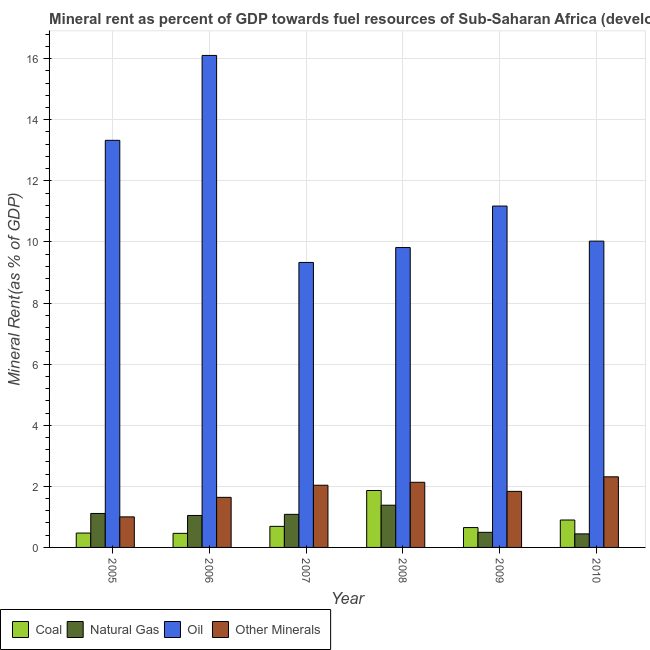How many different coloured bars are there?
Provide a succinct answer. 4. How many groups of bars are there?
Your response must be concise. 6. Are the number of bars per tick equal to the number of legend labels?
Make the answer very short. Yes. Are the number of bars on each tick of the X-axis equal?
Your response must be concise. Yes. What is the natural gas rent in 2006?
Provide a succinct answer. 1.05. Across all years, what is the maximum oil rent?
Ensure brevity in your answer.  16.1. Across all years, what is the minimum  rent of other minerals?
Provide a succinct answer. 1. In which year was the coal rent minimum?
Your answer should be very brief. 2006. What is the total oil rent in the graph?
Keep it short and to the point. 69.77. What is the difference between the natural gas rent in 2007 and that in 2010?
Your response must be concise. 0.64. What is the difference between the oil rent in 2008 and the natural gas rent in 2006?
Offer a terse response. -6.29. What is the average coal rent per year?
Ensure brevity in your answer.  0.84. In how many years, is the  rent of other minerals greater than 6.4 %?
Make the answer very short. 0. What is the ratio of the natural gas rent in 2005 to that in 2009?
Your answer should be compact. 2.25. Is the  rent of other minerals in 2005 less than that in 2006?
Provide a short and direct response. Yes. Is the difference between the coal rent in 2005 and 2007 greater than the difference between the oil rent in 2005 and 2007?
Give a very brief answer. No. What is the difference between the highest and the second highest coal rent?
Your response must be concise. 0.97. What is the difference between the highest and the lowest natural gas rent?
Make the answer very short. 0.94. Is the sum of the natural gas rent in 2006 and 2009 greater than the maximum oil rent across all years?
Offer a terse response. Yes. What does the 1st bar from the left in 2010 represents?
Offer a terse response. Coal. What does the 1st bar from the right in 2006 represents?
Make the answer very short. Other Minerals. Is it the case that in every year, the sum of the coal rent and natural gas rent is greater than the oil rent?
Make the answer very short. No. Are all the bars in the graph horizontal?
Give a very brief answer. No. How many years are there in the graph?
Your answer should be very brief. 6. What is the difference between two consecutive major ticks on the Y-axis?
Offer a very short reply. 2. Does the graph contain any zero values?
Provide a succinct answer. No. Does the graph contain grids?
Keep it short and to the point. Yes. How are the legend labels stacked?
Your answer should be compact. Horizontal. What is the title of the graph?
Offer a terse response. Mineral rent as percent of GDP towards fuel resources of Sub-Saharan Africa (developing only). Does "Other greenhouse gases" appear as one of the legend labels in the graph?
Give a very brief answer. No. What is the label or title of the X-axis?
Make the answer very short. Year. What is the label or title of the Y-axis?
Provide a short and direct response. Mineral Rent(as % of GDP). What is the Mineral Rent(as % of GDP) in Coal in 2005?
Your response must be concise. 0.47. What is the Mineral Rent(as % of GDP) in Natural Gas in 2005?
Your answer should be compact. 1.11. What is the Mineral Rent(as % of GDP) of Oil in 2005?
Provide a short and direct response. 13.33. What is the Mineral Rent(as % of GDP) in Other Minerals in 2005?
Your answer should be very brief. 1. What is the Mineral Rent(as % of GDP) of Coal in 2006?
Your response must be concise. 0.46. What is the Mineral Rent(as % of GDP) of Natural Gas in 2006?
Ensure brevity in your answer.  1.05. What is the Mineral Rent(as % of GDP) of Oil in 2006?
Your response must be concise. 16.1. What is the Mineral Rent(as % of GDP) of Other Minerals in 2006?
Make the answer very short. 1.64. What is the Mineral Rent(as % of GDP) of Coal in 2007?
Your response must be concise. 0.69. What is the Mineral Rent(as % of GDP) in Natural Gas in 2007?
Give a very brief answer. 1.08. What is the Mineral Rent(as % of GDP) of Oil in 2007?
Give a very brief answer. 9.33. What is the Mineral Rent(as % of GDP) in Other Minerals in 2007?
Provide a succinct answer. 2.04. What is the Mineral Rent(as % of GDP) in Coal in 2008?
Your answer should be compact. 1.86. What is the Mineral Rent(as % of GDP) in Natural Gas in 2008?
Ensure brevity in your answer.  1.38. What is the Mineral Rent(as % of GDP) in Oil in 2008?
Ensure brevity in your answer.  9.82. What is the Mineral Rent(as % of GDP) in Other Minerals in 2008?
Offer a very short reply. 2.13. What is the Mineral Rent(as % of GDP) of Coal in 2009?
Make the answer very short. 0.65. What is the Mineral Rent(as % of GDP) in Natural Gas in 2009?
Keep it short and to the point. 0.49. What is the Mineral Rent(as % of GDP) in Oil in 2009?
Give a very brief answer. 11.17. What is the Mineral Rent(as % of GDP) of Other Minerals in 2009?
Offer a terse response. 1.83. What is the Mineral Rent(as % of GDP) in Coal in 2010?
Provide a succinct answer. 0.9. What is the Mineral Rent(as % of GDP) in Natural Gas in 2010?
Your response must be concise. 0.44. What is the Mineral Rent(as % of GDP) of Oil in 2010?
Provide a succinct answer. 10.03. What is the Mineral Rent(as % of GDP) in Other Minerals in 2010?
Provide a succinct answer. 2.31. Across all years, what is the maximum Mineral Rent(as % of GDP) in Coal?
Offer a terse response. 1.86. Across all years, what is the maximum Mineral Rent(as % of GDP) in Natural Gas?
Your response must be concise. 1.38. Across all years, what is the maximum Mineral Rent(as % of GDP) in Oil?
Provide a succinct answer. 16.1. Across all years, what is the maximum Mineral Rent(as % of GDP) of Other Minerals?
Offer a very short reply. 2.31. Across all years, what is the minimum Mineral Rent(as % of GDP) of Coal?
Provide a short and direct response. 0.46. Across all years, what is the minimum Mineral Rent(as % of GDP) of Natural Gas?
Offer a terse response. 0.44. Across all years, what is the minimum Mineral Rent(as % of GDP) of Oil?
Give a very brief answer. 9.33. Across all years, what is the minimum Mineral Rent(as % of GDP) of Other Minerals?
Offer a very short reply. 1. What is the total Mineral Rent(as % of GDP) in Coal in the graph?
Your response must be concise. 5.03. What is the total Mineral Rent(as % of GDP) in Natural Gas in the graph?
Your response must be concise. 5.56. What is the total Mineral Rent(as % of GDP) of Oil in the graph?
Give a very brief answer. 69.77. What is the total Mineral Rent(as % of GDP) in Other Minerals in the graph?
Ensure brevity in your answer.  10.95. What is the difference between the Mineral Rent(as % of GDP) of Coal in 2005 and that in 2006?
Provide a succinct answer. 0.01. What is the difference between the Mineral Rent(as % of GDP) in Natural Gas in 2005 and that in 2006?
Your answer should be compact. 0.07. What is the difference between the Mineral Rent(as % of GDP) in Oil in 2005 and that in 2006?
Your answer should be very brief. -2.78. What is the difference between the Mineral Rent(as % of GDP) of Other Minerals in 2005 and that in 2006?
Make the answer very short. -0.64. What is the difference between the Mineral Rent(as % of GDP) in Coal in 2005 and that in 2007?
Provide a succinct answer. -0.22. What is the difference between the Mineral Rent(as % of GDP) in Natural Gas in 2005 and that in 2007?
Make the answer very short. 0.03. What is the difference between the Mineral Rent(as % of GDP) of Oil in 2005 and that in 2007?
Offer a terse response. 4. What is the difference between the Mineral Rent(as % of GDP) in Other Minerals in 2005 and that in 2007?
Offer a very short reply. -1.04. What is the difference between the Mineral Rent(as % of GDP) in Coal in 2005 and that in 2008?
Your response must be concise. -1.39. What is the difference between the Mineral Rent(as % of GDP) in Natural Gas in 2005 and that in 2008?
Ensure brevity in your answer.  -0.27. What is the difference between the Mineral Rent(as % of GDP) of Oil in 2005 and that in 2008?
Give a very brief answer. 3.51. What is the difference between the Mineral Rent(as % of GDP) in Other Minerals in 2005 and that in 2008?
Provide a succinct answer. -1.13. What is the difference between the Mineral Rent(as % of GDP) of Coal in 2005 and that in 2009?
Keep it short and to the point. -0.18. What is the difference between the Mineral Rent(as % of GDP) of Natural Gas in 2005 and that in 2009?
Provide a succinct answer. 0.62. What is the difference between the Mineral Rent(as % of GDP) of Oil in 2005 and that in 2009?
Keep it short and to the point. 2.15. What is the difference between the Mineral Rent(as % of GDP) in Other Minerals in 2005 and that in 2009?
Provide a short and direct response. -0.83. What is the difference between the Mineral Rent(as % of GDP) in Coal in 2005 and that in 2010?
Offer a very short reply. -0.43. What is the difference between the Mineral Rent(as % of GDP) in Natural Gas in 2005 and that in 2010?
Provide a succinct answer. 0.67. What is the difference between the Mineral Rent(as % of GDP) of Oil in 2005 and that in 2010?
Provide a short and direct response. 3.3. What is the difference between the Mineral Rent(as % of GDP) in Other Minerals in 2005 and that in 2010?
Offer a terse response. -1.31. What is the difference between the Mineral Rent(as % of GDP) in Coal in 2006 and that in 2007?
Your answer should be compact. -0.23. What is the difference between the Mineral Rent(as % of GDP) in Natural Gas in 2006 and that in 2007?
Provide a succinct answer. -0.04. What is the difference between the Mineral Rent(as % of GDP) in Oil in 2006 and that in 2007?
Your response must be concise. 6.78. What is the difference between the Mineral Rent(as % of GDP) in Other Minerals in 2006 and that in 2007?
Your answer should be compact. -0.4. What is the difference between the Mineral Rent(as % of GDP) in Coal in 2006 and that in 2008?
Provide a short and direct response. -1.4. What is the difference between the Mineral Rent(as % of GDP) of Natural Gas in 2006 and that in 2008?
Ensure brevity in your answer.  -0.34. What is the difference between the Mineral Rent(as % of GDP) of Oil in 2006 and that in 2008?
Your answer should be very brief. 6.29. What is the difference between the Mineral Rent(as % of GDP) in Other Minerals in 2006 and that in 2008?
Offer a terse response. -0.49. What is the difference between the Mineral Rent(as % of GDP) of Coal in 2006 and that in 2009?
Your answer should be very brief. -0.19. What is the difference between the Mineral Rent(as % of GDP) in Natural Gas in 2006 and that in 2009?
Ensure brevity in your answer.  0.55. What is the difference between the Mineral Rent(as % of GDP) of Oil in 2006 and that in 2009?
Your answer should be compact. 4.93. What is the difference between the Mineral Rent(as % of GDP) of Other Minerals in 2006 and that in 2009?
Provide a short and direct response. -0.19. What is the difference between the Mineral Rent(as % of GDP) of Coal in 2006 and that in 2010?
Make the answer very short. -0.44. What is the difference between the Mineral Rent(as % of GDP) in Natural Gas in 2006 and that in 2010?
Keep it short and to the point. 0.6. What is the difference between the Mineral Rent(as % of GDP) in Oil in 2006 and that in 2010?
Keep it short and to the point. 6.08. What is the difference between the Mineral Rent(as % of GDP) of Other Minerals in 2006 and that in 2010?
Ensure brevity in your answer.  -0.67. What is the difference between the Mineral Rent(as % of GDP) in Coal in 2007 and that in 2008?
Your answer should be compact. -1.17. What is the difference between the Mineral Rent(as % of GDP) in Natural Gas in 2007 and that in 2008?
Offer a terse response. -0.3. What is the difference between the Mineral Rent(as % of GDP) of Oil in 2007 and that in 2008?
Provide a succinct answer. -0.49. What is the difference between the Mineral Rent(as % of GDP) in Other Minerals in 2007 and that in 2008?
Provide a short and direct response. -0.1. What is the difference between the Mineral Rent(as % of GDP) of Coal in 2007 and that in 2009?
Provide a short and direct response. 0.04. What is the difference between the Mineral Rent(as % of GDP) of Natural Gas in 2007 and that in 2009?
Keep it short and to the point. 0.59. What is the difference between the Mineral Rent(as % of GDP) in Oil in 2007 and that in 2009?
Offer a terse response. -1.85. What is the difference between the Mineral Rent(as % of GDP) in Other Minerals in 2007 and that in 2009?
Give a very brief answer. 0.2. What is the difference between the Mineral Rent(as % of GDP) in Coal in 2007 and that in 2010?
Give a very brief answer. -0.21. What is the difference between the Mineral Rent(as % of GDP) in Natural Gas in 2007 and that in 2010?
Keep it short and to the point. 0.64. What is the difference between the Mineral Rent(as % of GDP) of Oil in 2007 and that in 2010?
Your response must be concise. -0.7. What is the difference between the Mineral Rent(as % of GDP) of Other Minerals in 2007 and that in 2010?
Your response must be concise. -0.28. What is the difference between the Mineral Rent(as % of GDP) of Coal in 2008 and that in 2009?
Make the answer very short. 1.21. What is the difference between the Mineral Rent(as % of GDP) in Natural Gas in 2008 and that in 2009?
Keep it short and to the point. 0.89. What is the difference between the Mineral Rent(as % of GDP) in Oil in 2008 and that in 2009?
Your answer should be compact. -1.36. What is the difference between the Mineral Rent(as % of GDP) of Other Minerals in 2008 and that in 2009?
Offer a very short reply. 0.3. What is the difference between the Mineral Rent(as % of GDP) in Coal in 2008 and that in 2010?
Make the answer very short. 0.97. What is the difference between the Mineral Rent(as % of GDP) of Natural Gas in 2008 and that in 2010?
Your answer should be compact. 0.94. What is the difference between the Mineral Rent(as % of GDP) of Oil in 2008 and that in 2010?
Ensure brevity in your answer.  -0.21. What is the difference between the Mineral Rent(as % of GDP) of Other Minerals in 2008 and that in 2010?
Provide a succinct answer. -0.18. What is the difference between the Mineral Rent(as % of GDP) of Coal in 2009 and that in 2010?
Your answer should be very brief. -0.25. What is the difference between the Mineral Rent(as % of GDP) of Natural Gas in 2009 and that in 2010?
Keep it short and to the point. 0.05. What is the difference between the Mineral Rent(as % of GDP) in Oil in 2009 and that in 2010?
Offer a very short reply. 1.15. What is the difference between the Mineral Rent(as % of GDP) of Other Minerals in 2009 and that in 2010?
Keep it short and to the point. -0.48. What is the difference between the Mineral Rent(as % of GDP) in Coal in 2005 and the Mineral Rent(as % of GDP) in Natural Gas in 2006?
Offer a very short reply. -0.58. What is the difference between the Mineral Rent(as % of GDP) in Coal in 2005 and the Mineral Rent(as % of GDP) in Oil in 2006?
Keep it short and to the point. -15.63. What is the difference between the Mineral Rent(as % of GDP) in Coal in 2005 and the Mineral Rent(as % of GDP) in Other Minerals in 2006?
Offer a very short reply. -1.17. What is the difference between the Mineral Rent(as % of GDP) in Natural Gas in 2005 and the Mineral Rent(as % of GDP) in Oil in 2006?
Make the answer very short. -14.99. What is the difference between the Mineral Rent(as % of GDP) of Natural Gas in 2005 and the Mineral Rent(as % of GDP) of Other Minerals in 2006?
Your response must be concise. -0.53. What is the difference between the Mineral Rent(as % of GDP) of Oil in 2005 and the Mineral Rent(as % of GDP) of Other Minerals in 2006?
Offer a very short reply. 11.69. What is the difference between the Mineral Rent(as % of GDP) in Coal in 2005 and the Mineral Rent(as % of GDP) in Natural Gas in 2007?
Offer a terse response. -0.61. What is the difference between the Mineral Rent(as % of GDP) in Coal in 2005 and the Mineral Rent(as % of GDP) in Oil in 2007?
Keep it short and to the point. -8.86. What is the difference between the Mineral Rent(as % of GDP) in Coal in 2005 and the Mineral Rent(as % of GDP) in Other Minerals in 2007?
Offer a very short reply. -1.57. What is the difference between the Mineral Rent(as % of GDP) in Natural Gas in 2005 and the Mineral Rent(as % of GDP) in Oil in 2007?
Keep it short and to the point. -8.22. What is the difference between the Mineral Rent(as % of GDP) in Natural Gas in 2005 and the Mineral Rent(as % of GDP) in Other Minerals in 2007?
Ensure brevity in your answer.  -0.92. What is the difference between the Mineral Rent(as % of GDP) of Oil in 2005 and the Mineral Rent(as % of GDP) of Other Minerals in 2007?
Ensure brevity in your answer.  11.29. What is the difference between the Mineral Rent(as % of GDP) in Coal in 2005 and the Mineral Rent(as % of GDP) in Natural Gas in 2008?
Your response must be concise. -0.91. What is the difference between the Mineral Rent(as % of GDP) in Coal in 2005 and the Mineral Rent(as % of GDP) in Oil in 2008?
Give a very brief answer. -9.35. What is the difference between the Mineral Rent(as % of GDP) in Coal in 2005 and the Mineral Rent(as % of GDP) in Other Minerals in 2008?
Make the answer very short. -1.66. What is the difference between the Mineral Rent(as % of GDP) in Natural Gas in 2005 and the Mineral Rent(as % of GDP) in Oil in 2008?
Your answer should be compact. -8.7. What is the difference between the Mineral Rent(as % of GDP) in Natural Gas in 2005 and the Mineral Rent(as % of GDP) in Other Minerals in 2008?
Keep it short and to the point. -1.02. What is the difference between the Mineral Rent(as % of GDP) in Oil in 2005 and the Mineral Rent(as % of GDP) in Other Minerals in 2008?
Your response must be concise. 11.19. What is the difference between the Mineral Rent(as % of GDP) of Coal in 2005 and the Mineral Rent(as % of GDP) of Natural Gas in 2009?
Offer a terse response. -0.02. What is the difference between the Mineral Rent(as % of GDP) of Coal in 2005 and the Mineral Rent(as % of GDP) of Oil in 2009?
Provide a short and direct response. -10.7. What is the difference between the Mineral Rent(as % of GDP) in Coal in 2005 and the Mineral Rent(as % of GDP) in Other Minerals in 2009?
Your answer should be compact. -1.36. What is the difference between the Mineral Rent(as % of GDP) in Natural Gas in 2005 and the Mineral Rent(as % of GDP) in Oil in 2009?
Offer a very short reply. -10.06. What is the difference between the Mineral Rent(as % of GDP) in Natural Gas in 2005 and the Mineral Rent(as % of GDP) in Other Minerals in 2009?
Your answer should be very brief. -0.72. What is the difference between the Mineral Rent(as % of GDP) of Oil in 2005 and the Mineral Rent(as % of GDP) of Other Minerals in 2009?
Offer a terse response. 11.49. What is the difference between the Mineral Rent(as % of GDP) of Coal in 2005 and the Mineral Rent(as % of GDP) of Natural Gas in 2010?
Keep it short and to the point. 0.03. What is the difference between the Mineral Rent(as % of GDP) in Coal in 2005 and the Mineral Rent(as % of GDP) in Oil in 2010?
Ensure brevity in your answer.  -9.56. What is the difference between the Mineral Rent(as % of GDP) of Coal in 2005 and the Mineral Rent(as % of GDP) of Other Minerals in 2010?
Ensure brevity in your answer.  -1.84. What is the difference between the Mineral Rent(as % of GDP) of Natural Gas in 2005 and the Mineral Rent(as % of GDP) of Oil in 2010?
Your answer should be very brief. -8.91. What is the difference between the Mineral Rent(as % of GDP) of Natural Gas in 2005 and the Mineral Rent(as % of GDP) of Other Minerals in 2010?
Give a very brief answer. -1.2. What is the difference between the Mineral Rent(as % of GDP) of Oil in 2005 and the Mineral Rent(as % of GDP) of Other Minerals in 2010?
Ensure brevity in your answer.  11.01. What is the difference between the Mineral Rent(as % of GDP) in Coal in 2006 and the Mineral Rent(as % of GDP) in Natural Gas in 2007?
Provide a short and direct response. -0.62. What is the difference between the Mineral Rent(as % of GDP) of Coal in 2006 and the Mineral Rent(as % of GDP) of Oil in 2007?
Keep it short and to the point. -8.87. What is the difference between the Mineral Rent(as % of GDP) of Coal in 2006 and the Mineral Rent(as % of GDP) of Other Minerals in 2007?
Give a very brief answer. -1.57. What is the difference between the Mineral Rent(as % of GDP) in Natural Gas in 2006 and the Mineral Rent(as % of GDP) in Oil in 2007?
Your answer should be very brief. -8.28. What is the difference between the Mineral Rent(as % of GDP) of Natural Gas in 2006 and the Mineral Rent(as % of GDP) of Other Minerals in 2007?
Your answer should be very brief. -0.99. What is the difference between the Mineral Rent(as % of GDP) in Oil in 2006 and the Mineral Rent(as % of GDP) in Other Minerals in 2007?
Your response must be concise. 14.07. What is the difference between the Mineral Rent(as % of GDP) in Coal in 2006 and the Mineral Rent(as % of GDP) in Natural Gas in 2008?
Make the answer very short. -0.92. What is the difference between the Mineral Rent(as % of GDP) in Coal in 2006 and the Mineral Rent(as % of GDP) in Oil in 2008?
Provide a succinct answer. -9.35. What is the difference between the Mineral Rent(as % of GDP) of Coal in 2006 and the Mineral Rent(as % of GDP) of Other Minerals in 2008?
Give a very brief answer. -1.67. What is the difference between the Mineral Rent(as % of GDP) of Natural Gas in 2006 and the Mineral Rent(as % of GDP) of Oil in 2008?
Your response must be concise. -8.77. What is the difference between the Mineral Rent(as % of GDP) in Natural Gas in 2006 and the Mineral Rent(as % of GDP) in Other Minerals in 2008?
Offer a terse response. -1.09. What is the difference between the Mineral Rent(as % of GDP) in Oil in 2006 and the Mineral Rent(as % of GDP) in Other Minerals in 2008?
Your response must be concise. 13.97. What is the difference between the Mineral Rent(as % of GDP) in Coal in 2006 and the Mineral Rent(as % of GDP) in Natural Gas in 2009?
Provide a succinct answer. -0.03. What is the difference between the Mineral Rent(as % of GDP) of Coal in 2006 and the Mineral Rent(as % of GDP) of Oil in 2009?
Your answer should be very brief. -10.71. What is the difference between the Mineral Rent(as % of GDP) of Coal in 2006 and the Mineral Rent(as % of GDP) of Other Minerals in 2009?
Provide a short and direct response. -1.37. What is the difference between the Mineral Rent(as % of GDP) in Natural Gas in 2006 and the Mineral Rent(as % of GDP) in Oil in 2009?
Make the answer very short. -10.13. What is the difference between the Mineral Rent(as % of GDP) in Natural Gas in 2006 and the Mineral Rent(as % of GDP) in Other Minerals in 2009?
Your answer should be compact. -0.79. What is the difference between the Mineral Rent(as % of GDP) in Oil in 2006 and the Mineral Rent(as % of GDP) in Other Minerals in 2009?
Your answer should be compact. 14.27. What is the difference between the Mineral Rent(as % of GDP) of Coal in 2006 and the Mineral Rent(as % of GDP) of Natural Gas in 2010?
Give a very brief answer. 0.02. What is the difference between the Mineral Rent(as % of GDP) of Coal in 2006 and the Mineral Rent(as % of GDP) of Oil in 2010?
Your answer should be very brief. -9.57. What is the difference between the Mineral Rent(as % of GDP) of Coal in 2006 and the Mineral Rent(as % of GDP) of Other Minerals in 2010?
Provide a short and direct response. -1.85. What is the difference between the Mineral Rent(as % of GDP) of Natural Gas in 2006 and the Mineral Rent(as % of GDP) of Oil in 2010?
Your answer should be compact. -8.98. What is the difference between the Mineral Rent(as % of GDP) of Natural Gas in 2006 and the Mineral Rent(as % of GDP) of Other Minerals in 2010?
Provide a short and direct response. -1.26. What is the difference between the Mineral Rent(as % of GDP) of Oil in 2006 and the Mineral Rent(as % of GDP) of Other Minerals in 2010?
Offer a terse response. 13.79. What is the difference between the Mineral Rent(as % of GDP) of Coal in 2007 and the Mineral Rent(as % of GDP) of Natural Gas in 2008?
Your answer should be compact. -0.69. What is the difference between the Mineral Rent(as % of GDP) in Coal in 2007 and the Mineral Rent(as % of GDP) in Oil in 2008?
Provide a succinct answer. -9.13. What is the difference between the Mineral Rent(as % of GDP) of Coal in 2007 and the Mineral Rent(as % of GDP) of Other Minerals in 2008?
Your answer should be compact. -1.44. What is the difference between the Mineral Rent(as % of GDP) of Natural Gas in 2007 and the Mineral Rent(as % of GDP) of Oil in 2008?
Provide a short and direct response. -8.73. What is the difference between the Mineral Rent(as % of GDP) in Natural Gas in 2007 and the Mineral Rent(as % of GDP) in Other Minerals in 2008?
Offer a terse response. -1.05. What is the difference between the Mineral Rent(as % of GDP) in Oil in 2007 and the Mineral Rent(as % of GDP) in Other Minerals in 2008?
Offer a very short reply. 7.2. What is the difference between the Mineral Rent(as % of GDP) of Coal in 2007 and the Mineral Rent(as % of GDP) of Natural Gas in 2009?
Provide a short and direct response. 0.19. What is the difference between the Mineral Rent(as % of GDP) in Coal in 2007 and the Mineral Rent(as % of GDP) in Oil in 2009?
Keep it short and to the point. -10.48. What is the difference between the Mineral Rent(as % of GDP) in Coal in 2007 and the Mineral Rent(as % of GDP) in Other Minerals in 2009?
Your response must be concise. -1.15. What is the difference between the Mineral Rent(as % of GDP) in Natural Gas in 2007 and the Mineral Rent(as % of GDP) in Oil in 2009?
Make the answer very short. -10.09. What is the difference between the Mineral Rent(as % of GDP) of Natural Gas in 2007 and the Mineral Rent(as % of GDP) of Other Minerals in 2009?
Your answer should be very brief. -0.75. What is the difference between the Mineral Rent(as % of GDP) in Oil in 2007 and the Mineral Rent(as % of GDP) in Other Minerals in 2009?
Provide a succinct answer. 7.49. What is the difference between the Mineral Rent(as % of GDP) of Coal in 2007 and the Mineral Rent(as % of GDP) of Natural Gas in 2010?
Your response must be concise. 0.25. What is the difference between the Mineral Rent(as % of GDP) of Coal in 2007 and the Mineral Rent(as % of GDP) of Oil in 2010?
Make the answer very short. -9.34. What is the difference between the Mineral Rent(as % of GDP) in Coal in 2007 and the Mineral Rent(as % of GDP) in Other Minerals in 2010?
Your answer should be compact. -1.62. What is the difference between the Mineral Rent(as % of GDP) in Natural Gas in 2007 and the Mineral Rent(as % of GDP) in Oil in 2010?
Your response must be concise. -8.94. What is the difference between the Mineral Rent(as % of GDP) of Natural Gas in 2007 and the Mineral Rent(as % of GDP) of Other Minerals in 2010?
Provide a short and direct response. -1.23. What is the difference between the Mineral Rent(as % of GDP) in Oil in 2007 and the Mineral Rent(as % of GDP) in Other Minerals in 2010?
Provide a short and direct response. 7.02. What is the difference between the Mineral Rent(as % of GDP) of Coal in 2008 and the Mineral Rent(as % of GDP) of Natural Gas in 2009?
Give a very brief answer. 1.37. What is the difference between the Mineral Rent(as % of GDP) in Coal in 2008 and the Mineral Rent(as % of GDP) in Oil in 2009?
Offer a very short reply. -9.31. What is the difference between the Mineral Rent(as % of GDP) in Coal in 2008 and the Mineral Rent(as % of GDP) in Other Minerals in 2009?
Your answer should be compact. 0.03. What is the difference between the Mineral Rent(as % of GDP) of Natural Gas in 2008 and the Mineral Rent(as % of GDP) of Oil in 2009?
Offer a terse response. -9.79. What is the difference between the Mineral Rent(as % of GDP) in Natural Gas in 2008 and the Mineral Rent(as % of GDP) in Other Minerals in 2009?
Keep it short and to the point. -0.45. What is the difference between the Mineral Rent(as % of GDP) of Oil in 2008 and the Mineral Rent(as % of GDP) of Other Minerals in 2009?
Offer a terse response. 7.98. What is the difference between the Mineral Rent(as % of GDP) of Coal in 2008 and the Mineral Rent(as % of GDP) of Natural Gas in 2010?
Your answer should be compact. 1.42. What is the difference between the Mineral Rent(as % of GDP) in Coal in 2008 and the Mineral Rent(as % of GDP) in Oil in 2010?
Make the answer very short. -8.16. What is the difference between the Mineral Rent(as % of GDP) in Coal in 2008 and the Mineral Rent(as % of GDP) in Other Minerals in 2010?
Your answer should be very brief. -0.45. What is the difference between the Mineral Rent(as % of GDP) in Natural Gas in 2008 and the Mineral Rent(as % of GDP) in Oil in 2010?
Ensure brevity in your answer.  -8.64. What is the difference between the Mineral Rent(as % of GDP) in Natural Gas in 2008 and the Mineral Rent(as % of GDP) in Other Minerals in 2010?
Your response must be concise. -0.93. What is the difference between the Mineral Rent(as % of GDP) of Oil in 2008 and the Mineral Rent(as % of GDP) of Other Minerals in 2010?
Offer a terse response. 7.5. What is the difference between the Mineral Rent(as % of GDP) in Coal in 2009 and the Mineral Rent(as % of GDP) in Natural Gas in 2010?
Offer a terse response. 0.21. What is the difference between the Mineral Rent(as % of GDP) in Coal in 2009 and the Mineral Rent(as % of GDP) in Oil in 2010?
Your answer should be very brief. -9.38. What is the difference between the Mineral Rent(as % of GDP) in Coal in 2009 and the Mineral Rent(as % of GDP) in Other Minerals in 2010?
Give a very brief answer. -1.66. What is the difference between the Mineral Rent(as % of GDP) in Natural Gas in 2009 and the Mineral Rent(as % of GDP) in Oil in 2010?
Provide a short and direct response. -9.53. What is the difference between the Mineral Rent(as % of GDP) of Natural Gas in 2009 and the Mineral Rent(as % of GDP) of Other Minerals in 2010?
Ensure brevity in your answer.  -1.82. What is the difference between the Mineral Rent(as % of GDP) in Oil in 2009 and the Mineral Rent(as % of GDP) in Other Minerals in 2010?
Give a very brief answer. 8.86. What is the average Mineral Rent(as % of GDP) in Coal per year?
Make the answer very short. 0.84. What is the average Mineral Rent(as % of GDP) of Natural Gas per year?
Ensure brevity in your answer.  0.93. What is the average Mineral Rent(as % of GDP) of Oil per year?
Offer a very short reply. 11.63. What is the average Mineral Rent(as % of GDP) in Other Minerals per year?
Your response must be concise. 1.83. In the year 2005, what is the difference between the Mineral Rent(as % of GDP) of Coal and Mineral Rent(as % of GDP) of Natural Gas?
Provide a succinct answer. -0.64. In the year 2005, what is the difference between the Mineral Rent(as % of GDP) in Coal and Mineral Rent(as % of GDP) in Oil?
Your answer should be compact. -12.86. In the year 2005, what is the difference between the Mineral Rent(as % of GDP) of Coal and Mineral Rent(as % of GDP) of Other Minerals?
Offer a terse response. -0.53. In the year 2005, what is the difference between the Mineral Rent(as % of GDP) in Natural Gas and Mineral Rent(as % of GDP) in Oil?
Your answer should be compact. -12.21. In the year 2005, what is the difference between the Mineral Rent(as % of GDP) in Natural Gas and Mineral Rent(as % of GDP) in Other Minerals?
Provide a succinct answer. 0.11. In the year 2005, what is the difference between the Mineral Rent(as % of GDP) in Oil and Mineral Rent(as % of GDP) in Other Minerals?
Offer a very short reply. 12.33. In the year 2006, what is the difference between the Mineral Rent(as % of GDP) in Coal and Mineral Rent(as % of GDP) in Natural Gas?
Provide a succinct answer. -0.59. In the year 2006, what is the difference between the Mineral Rent(as % of GDP) of Coal and Mineral Rent(as % of GDP) of Oil?
Keep it short and to the point. -15.64. In the year 2006, what is the difference between the Mineral Rent(as % of GDP) in Coal and Mineral Rent(as % of GDP) in Other Minerals?
Provide a short and direct response. -1.18. In the year 2006, what is the difference between the Mineral Rent(as % of GDP) of Natural Gas and Mineral Rent(as % of GDP) of Oil?
Your answer should be very brief. -15.06. In the year 2006, what is the difference between the Mineral Rent(as % of GDP) in Natural Gas and Mineral Rent(as % of GDP) in Other Minerals?
Offer a terse response. -0.59. In the year 2006, what is the difference between the Mineral Rent(as % of GDP) of Oil and Mineral Rent(as % of GDP) of Other Minerals?
Make the answer very short. 14.47. In the year 2007, what is the difference between the Mineral Rent(as % of GDP) of Coal and Mineral Rent(as % of GDP) of Natural Gas?
Provide a succinct answer. -0.39. In the year 2007, what is the difference between the Mineral Rent(as % of GDP) of Coal and Mineral Rent(as % of GDP) of Oil?
Ensure brevity in your answer.  -8.64. In the year 2007, what is the difference between the Mineral Rent(as % of GDP) in Coal and Mineral Rent(as % of GDP) in Other Minerals?
Offer a terse response. -1.35. In the year 2007, what is the difference between the Mineral Rent(as % of GDP) of Natural Gas and Mineral Rent(as % of GDP) of Oil?
Your answer should be compact. -8.25. In the year 2007, what is the difference between the Mineral Rent(as % of GDP) in Natural Gas and Mineral Rent(as % of GDP) in Other Minerals?
Your answer should be compact. -0.95. In the year 2007, what is the difference between the Mineral Rent(as % of GDP) of Oil and Mineral Rent(as % of GDP) of Other Minerals?
Provide a succinct answer. 7.29. In the year 2008, what is the difference between the Mineral Rent(as % of GDP) of Coal and Mineral Rent(as % of GDP) of Natural Gas?
Your answer should be compact. 0.48. In the year 2008, what is the difference between the Mineral Rent(as % of GDP) in Coal and Mineral Rent(as % of GDP) in Oil?
Your answer should be compact. -7.95. In the year 2008, what is the difference between the Mineral Rent(as % of GDP) of Coal and Mineral Rent(as % of GDP) of Other Minerals?
Provide a short and direct response. -0.27. In the year 2008, what is the difference between the Mineral Rent(as % of GDP) of Natural Gas and Mineral Rent(as % of GDP) of Oil?
Make the answer very short. -8.43. In the year 2008, what is the difference between the Mineral Rent(as % of GDP) of Natural Gas and Mineral Rent(as % of GDP) of Other Minerals?
Provide a succinct answer. -0.75. In the year 2008, what is the difference between the Mineral Rent(as % of GDP) of Oil and Mineral Rent(as % of GDP) of Other Minerals?
Give a very brief answer. 7.68. In the year 2009, what is the difference between the Mineral Rent(as % of GDP) in Coal and Mineral Rent(as % of GDP) in Natural Gas?
Provide a succinct answer. 0.16. In the year 2009, what is the difference between the Mineral Rent(as % of GDP) in Coal and Mineral Rent(as % of GDP) in Oil?
Ensure brevity in your answer.  -10.52. In the year 2009, what is the difference between the Mineral Rent(as % of GDP) in Coal and Mineral Rent(as % of GDP) in Other Minerals?
Keep it short and to the point. -1.18. In the year 2009, what is the difference between the Mineral Rent(as % of GDP) of Natural Gas and Mineral Rent(as % of GDP) of Oil?
Your answer should be compact. -10.68. In the year 2009, what is the difference between the Mineral Rent(as % of GDP) in Natural Gas and Mineral Rent(as % of GDP) in Other Minerals?
Make the answer very short. -1.34. In the year 2009, what is the difference between the Mineral Rent(as % of GDP) of Oil and Mineral Rent(as % of GDP) of Other Minerals?
Give a very brief answer. 9.34. In the year 2010, what is the difference between the Mineral Rent(as % of GDP) of Coal and Mineral Rent(as % of GDP) of Natural Gas?
Give a very brief answer. 0.45. In the year 2010, what is the difference between the Mineral Rent(as % of GDP) of Coal and Mineral Rent(as % of GDP) of Oil?
Provide a succinct answer. -9.13. In the year 2010, what is the difference between the Mineral Rent(as % of GDP) of Coal and Mineral Rent(as % of GDP) of Other Minerals?
Provide a short and direct response. -1.41. In the year 2010, what is the difference between the Mineral Rent(as % of GDP) of Natural Gas and Mineral Rent(as % of GDP) of Oil?
Keep it short and to the point. -9.58. In the year 2010, what is the difference between the Mineral Rent(as % of GDP) in Natural Gas and Mineral Rent(as % of GDP) in Other Minerals?
Make the answer very short. -1.87. In the year 2010, what is the difference between the Mineral Rent(as % of GDP) of Oil and Mineral Rent(as % of GDP) of Other Minerals?
Give a very brief answer. 7.72. What is the ratio of the Mineral Rent(as % of GDP) in Coal in 2005 to that in 2006?
Your answer should be very brief. 1.02. What is the ratio of the Mineral Rent(as % of GDP) of Natural Gas in 2005 to that in 2006?
Provide a short and direct response. 1.06. What is the ratio of the Mineral Rent(as % of GDP) of Oil in 2005 to that in 2006?
Your response must be concise. 0.83. What is the ratio of the Mineral Rent(as % of GDP) of Other Minerals in 2005 to that in 2006?
Your answer should be very brief. 0.61. What is the ratio of the Mineral Rent(as % of GDP) of Coal in 2005 to that in 2007?
Give a very brief answer. 0.68. What is the ratio of the Mineral Rent(as % of GDP) of Natural Gas in 2005 to that in 2007?
Your answer should be compact. 1.03. What is the ratio of the Mineral Rent(as % of GDP) of Oil in 2005 to that in 2007?
Offer a very short reply. 1.43. What is the ratio of the Mineral Rent(as % of GDP) of Other Minerals in 2005 to that in 2007?
Your response must be concise. 0.49. What is the ratio of the Mineral Rent(as % of GDP) in Coal in 2005 to that in 2008?
Give a very brief answer. 0.25. What is the ratio of the Mineral Rent(as % of GDP) in Natural Gas in 2005 to that in 2008?
Provide a short and direct response. 0.8. What is the ratio of the Mineral Rent(as % of GDP) in Oil in 2005 to that in 2008?
Give a very brief answer. 1.36. What is the ratio of the Mineral Rent(as % of GDP) in Other Minerals in 2005 to that in 2008?
Keep it short and to the point. 0.47. What is the ratio of the Mineral Rent(as % of GDP) of Coal in 2005 to that in 2009?
Your response must be concise. 0.72. What is the ratio of the Mineral Rent(as % of GDP) of Natural Gas in 2005 to that in 2009?
Keep it short and to the point. 2.25. What is the ratio of the Mineral Rent(as % of GDP) of Oil in 2005 to that in 2009?
Your answer should be compact. 1.19. What is the ratio of the Mineral Rent(as % of GDP) in Other Minerals in 2005 to that in 2009?
Your answer should be compact. 0.55. What is the ratio of the Mineral Rent(as % of GDP) in Coal in 2005 to that in 2010?
Offer a very short reply. 0.52. What is the ratio of the Mineral Rent(as % of GDP) of Natural Gas in 2005 to that in 2010?
Offer a very short reply. 2.51. What is the ratio of the Mineral Rent(as % of GDP) of Oil in 2005 to that in 2010?
Keep it short and to the point. 1.33. What is the ratio of the Mineral Rent(as % of GDP) in Other Minerals in 2005 to that in 2010?
Give a very brief answer. 0.43. What is the ratio of the Mineral Rent(as % of GDP) in Coal in 2006 to that in 2007?
Your response must be concise. 0.67. What is the ratio of the Mineral Rent(as % of GDP) of Natural Gas in 2006 to that in 2007?
Give a very brief answer. 0.97. What is the ratio of the Mineral Rent(as % of GDP) in Oil in 2006 to that in 2007?
Your answer should be very brief. 1.73. What is the ratio of the Mineral Rent(as % of GDP) of Other Minerals in 2006 to that in 2007?
Provide a short and direct response. 0.81. What is the ratio of the Mineral Rent(as % of GDP) of Coal in 2006 to that in 2008?
Offer a terse response. 0.25. What is the ratio of the Mineral Rent(as % of GDP) in Natural Gas in 2006 to that in 2008?
Make the answer very short. 0.76. What is the ratio of the Mineral Rent(as % of GDP) in Oil in 2006 to that in 2008?
Provide a succinct answer. 1.64. What is the ratio of the Mineral Rent(as % of GDP) of Other Minerals in 2006 to that in 2008?
Offer a very short reply. 0.77. What is the ratio of the Mineral Rent(as % of GDP) of Coal in 2006 to that in 2009?
Your response must be concise. 0.71. What is the ratio of the Mineral Rent(as % of GDP) in Natural Gas in 2006 to that in 2009?
Give a very brief answer. 2.12. What is the ratio of the Mineral Rent(as % of GDP) of Oil in 2006 to that in 2009?
Ensure brevity in your answer.  1.44. What is the ratio of the Mineral Rent(as % of GDP) of Other Minerals in 2006 to that in 2009?
Offer a terse response. 0.89. What is the ratio of the Mineral Rent(as % of GDP) of Coal in 2006 to that in 2010?
Give a very brief answer. 0.51. What is the ratio of the Mineral Rent(as % of GDP) of Natural Gas in 2006 to that in 2010?
Your response must be concise. 2.36. What is the ratio of the Mineral Rent(as % of GDP) of Oil in 2006 to that in 2010?
Keep it short and to the point. 1.61. What is the ratio of the Mineral Rent(as % of GDP) of Other Minerals in 2006 to that in 2010?
Ensure brevity in your answer.  0.71. What is the ratio of the Mineral Rent(as % of GDP) in Coal in 2007 to that in 2008?
Your answer should be compact. 0.37. What is the ratio of the Mineral Rent(as % of GDP) in Natural Gas in 2007 to that in 2008?
Keep it short and to the point. 0.78. What is the ratio of the Mineral Rent(as % of GDP) in Oil in 2007 to that in 2008?
Provide a succinct answer. 0.95. What is the ratio of the Mineral Rent(as % of GDP) of Other Minerals in 2007 to that in 2008?
Make the answer very short. 0.95. What is the ratio of the Mineral Rent(as % of GDP) in Coal in 2007 to that in 2009?
Ensure brevity in your answer.  1.06. What is the ratio of the Mineral Rent(as % of GDP) in Natural Gas in 2007 to that in 2009?
Your answer should be compact. 2.19. What is the ratio of the Mineral Rent(as % of GDP) in Oil in 2007 to that in 2009?
Provide a short and direct response. 0.83. What is the ratio of the Mineral Rent(as % of GDP) in Other Minerals in 2007 to that in 2009?
Your answer should be very brief. 1.11. What is the ratio of the Mineral Rent(as % of GDP) in Coal in 2007 to that in 2010?
Offer a very short reply. 0.77. What is the ratio of the Mineral Rent(as % of GDP) of Natural Gas in 2007 to that in 2010?
Make the answer very short. 2.44. What is the ratio of the Mineral Rent(as % of GDP) of Oil in 2007 to that in 2010?
Offer a terse response. 0.93. What is the ratio of the Mineral Rent(as % of GDP) in Other Minerals in 2007 to that in 2010?
Keep it short and to the point. 0.88. What is the ratio of the Mineral Rent(as % of GDP) in Coal in 2008 to that in 2009?
Ensure brevity in your answer.  2.87. What is the ratio of the Mineral Rent(as % of GDP) in Natural Gas in 2008 to that in 2009?
Keep it short and to the point. 2.79. What is the ratio of the Mineral Rent(as % of GDP) of Oil in 2008 to that in 2009?
Make the answer very short. 0.88. What is the ratio of the Mineral Rent(as % of GDP) of Other Minerals in 2008 to that in 2009?
Your answer should be very brief. 1.16. What is the ratio of the Mineral Rent(as % of GDP) in Coal in 2008 to that in 2010?
Ensure brevity in your answer.  2.08. What is the ratio of the Mineral Rent(as % of GDP) of Natural Gas in 2008 to that in 2010?
Give a very brief answer. 3.12. What is the ratio of the Mineral Rent(as % of GDP) of Other Minerals in 2008 to that in 2010?
Give a very brief answer. 0.92. What is the ratio of the Mineral Rent(as % of GDP) in Coal in 2009 to that in 2010?
Offer a terse response. 0.72. What is the ratio of the Mineral Rent(as % of GDP) in Natural Gas in 2009 to that in 2010?
Provide a short and direct response. 1.11. What is the ratio of the Mineral Rent(as % of GDP) of Oil in 2009 to that in 2010?
Provide a short and direct response. 1.11. What is the ratio of the Mineral Rent(as % of GDP) in Other Minerals in 2009 to that in 2010?
Provide a succinct answer. 0.79. What is the difference between the highest and the second highest Mineral Rent(as % of GDP) in Coal?
Your response must be concise. 0.97. What is the difference between the highest and the second highest Mineral Rent(as % of GDP) of Natural Gas?
Your answer should be very brief. 0.27. What is the difference between the highest and the second highest Mineral Rent(as % of GDP) in Oil?
Your response must be concise. 2.78. What is the difference between the highest and the second highest Mineral Rent(as % of GDP) of Other Minerals?
Keep it short and to the point. 0.18. What is the difference between the highest and the lowest Mineral Rent(as % of GDP) in Coal?
Keep it short and to the point. 1.4. What is the difference between the highest and the lowest Mineral Rent(as % of GDP) in Natural Gas?
Offer a terse response. 0.94. What is the difference between the highest and the lowest Mineral Rent(as % of GDP) of Oil?
Give a very brief answer. 6.78. What is the difference between the highest and the lowest Mineral Rent(as % of GDP) of Other Minerals?
Give a very brief answer. 1.31. 